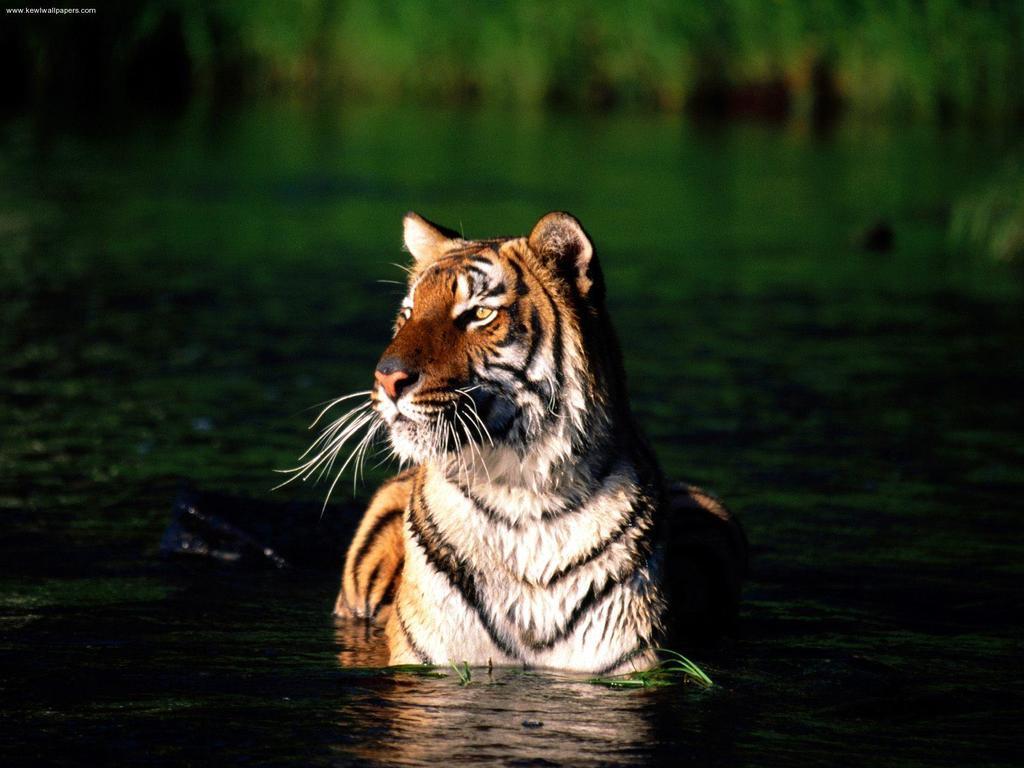In one or two sentences, can you explain what this image depicts? In the center of the image we can see a tiger is present in the water. In the background, the image is blur. In the top left corner we can see the text. 